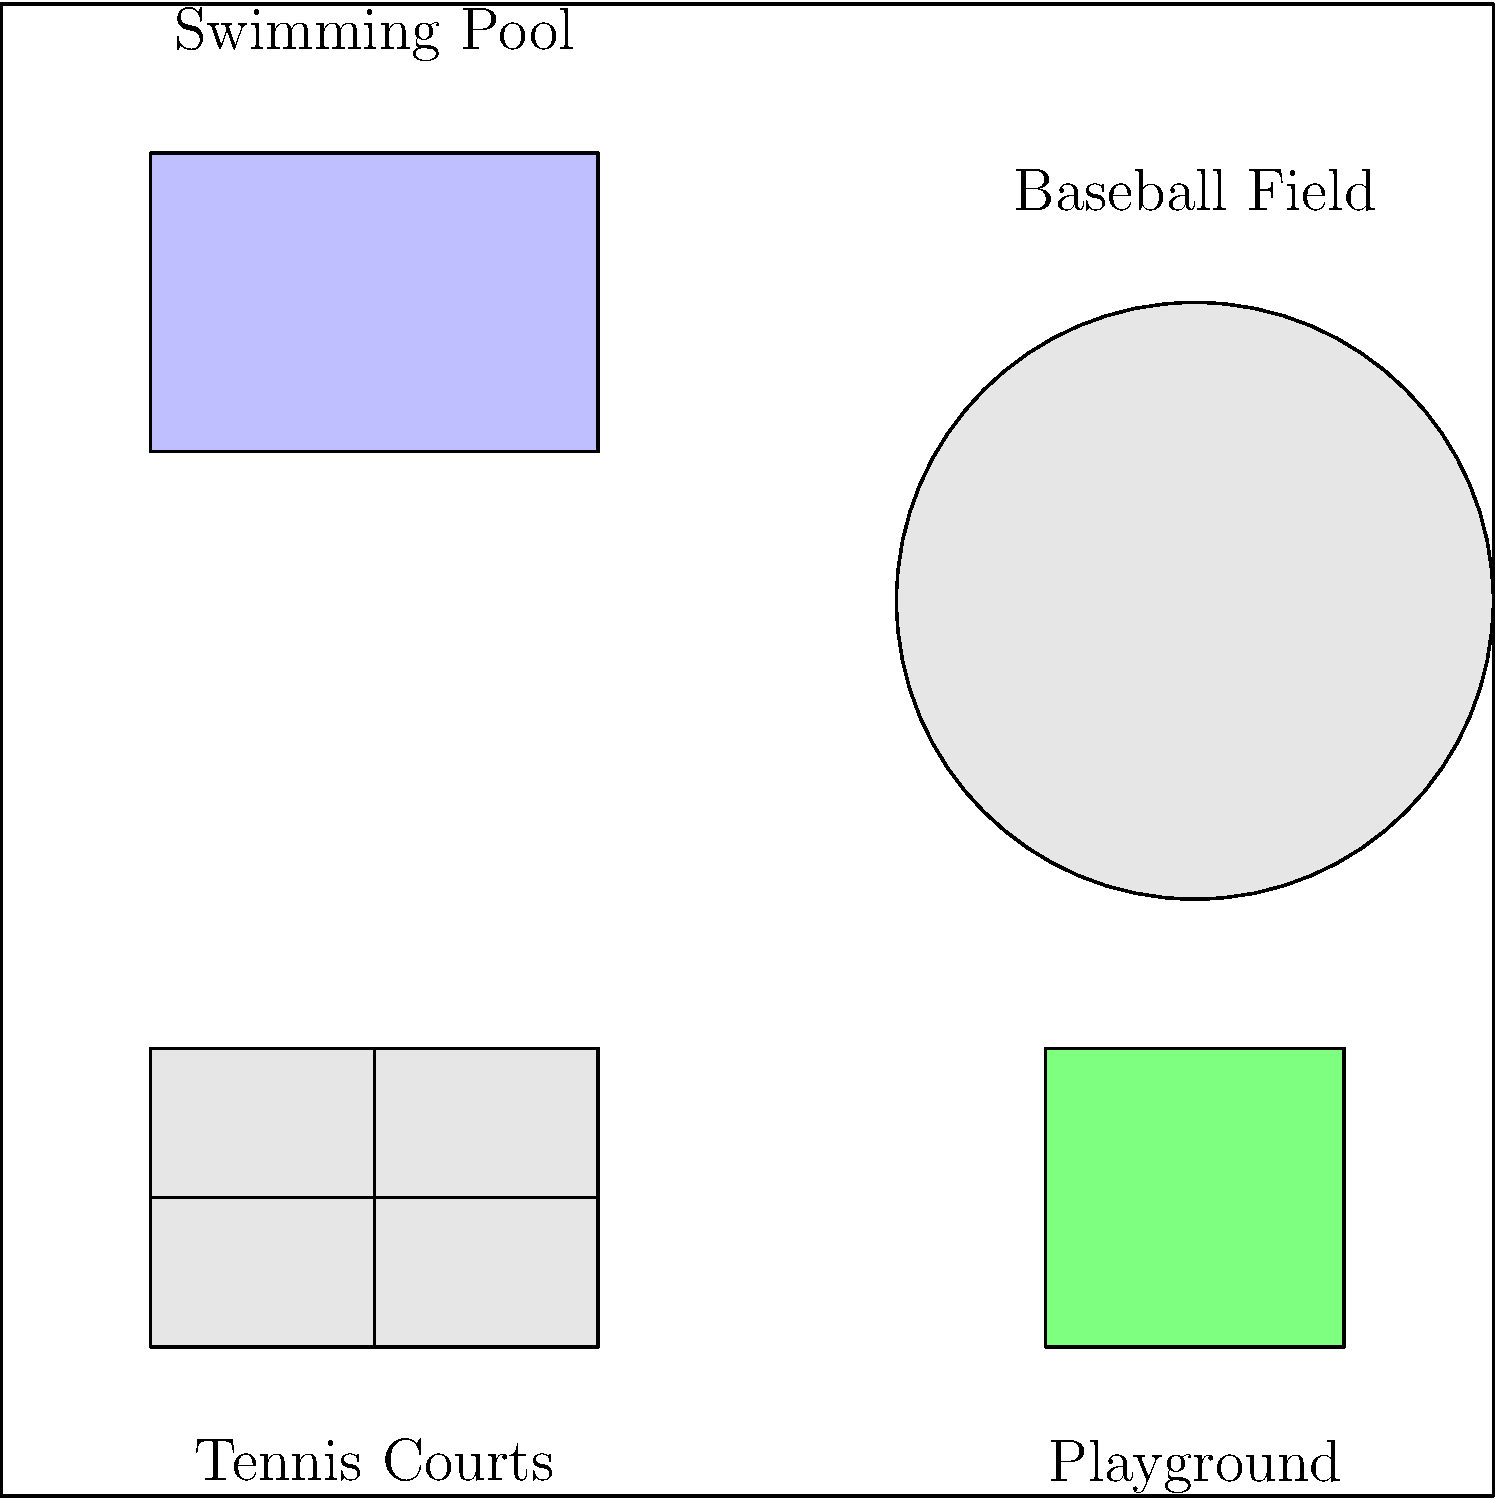In the given park plan, which recreational facility is located in the northeastern quadrant of the park? To answer this question, we need to analyze the park plan and identify the recreational facilities in each quadrant. Let's break it down step-by-step:

1. First, we need to understand the orientation of the park plan. In most cases, the top of the image represents north, the bottom represents south, the right side represents east, and the left side represents west.

2. We can divide the park into four quadrants: northwest (top-left), northeast (top-right), southwest (bottom-left), and southeast (bottom-right).

3. Let's identify the facilities in each quadrant:
   - Northwest (top-left): Swimming pool
   - Northeast (top-right): Baseball field
   - Southwest (bottom-left): Tennis courts
   - Southeast (bottom-right): Playground

4. The question asks specifically about the northeastern quadrant, which is the top-right section of the park plan.

5. In the northeastern quadrant, we can clearly see a baseball field, represented by a diamond shape with a circular infield.

Therefore, the recreational facility located in the northeastern quadrant of the park is the baseball field.
Answer: Baseball field 